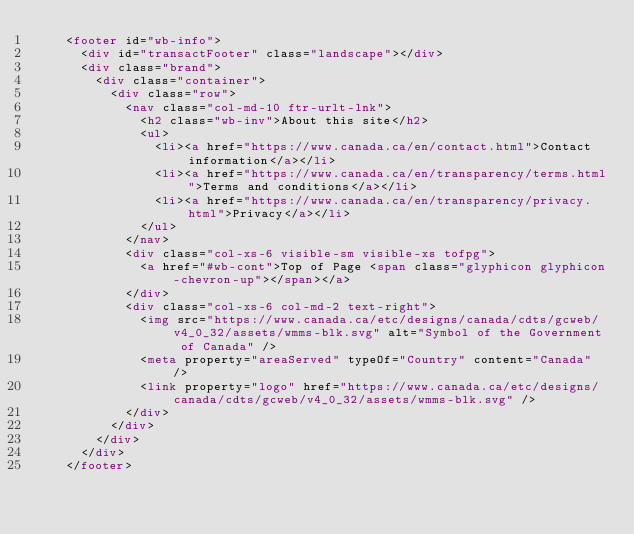<code> <loc_0><loc_0><loc_500><loc_500><_HTML_>		<footer id="wb-info">
			<div id="transactFooter" class="landscape"></div>
			<div class="brand">
				<div class="container">
					<div class="row">
						<nav class="col-md-10 ftr-urlt-lnk">
							<h2 class="wb-inv">About this site</h2>
							<ul>
								<li><a href="https://www.canada.ca/en/contact.html">Contact information</a></li>
								<li><a href="https://www.canada.ca/en/transparency/terms.html">Terms and conditions</a></li>
								<li><a href="https://www.canada.ca/en/transparency/privacy.html">Privacy</a></li>
							</ul>
						</nav>
						<div class="col-xs-6 visible-sm visible-xs tofpg">
							<a href="#wb-cont">Top of Page <span class="glyphicon glyphicon-chevron-up"></span></a>
						</div>
						<div class="col-xs-6 col-md-2 text-right">
							<img src="https://www.canada.ca/etc/designs/canada/cdts/gcweb/v4_0_32/assets/wmms-blk.svg" alt="Symbol of the Government of Canada" />
							<meta property="areaServed" typeOf="Country" content="Canada" />
							<link property="logo" href="https://www.canada.ca/etc/designs/canada/cdts/gcweb/v4_0_32/assets/wmms-blk.svg" />
						</div>
					</div>
				</div>
			</div>
		</footer></code> 